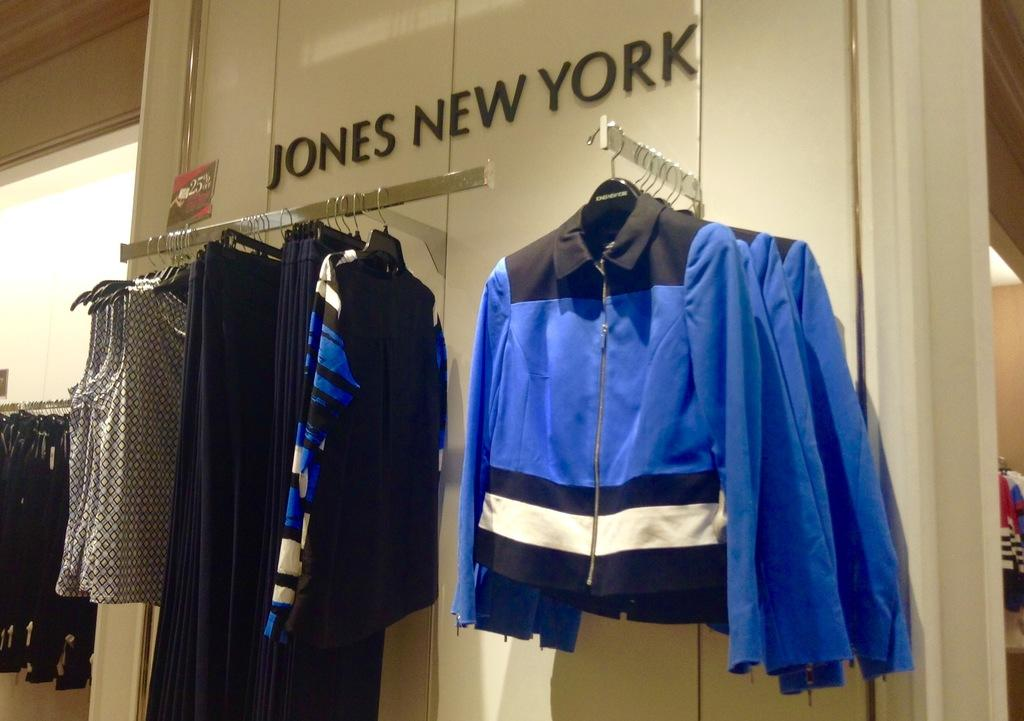<image>
Offer a succinct explanation of the picture presented. Clothes are hanging in a store by a sign saying Jones New York. 